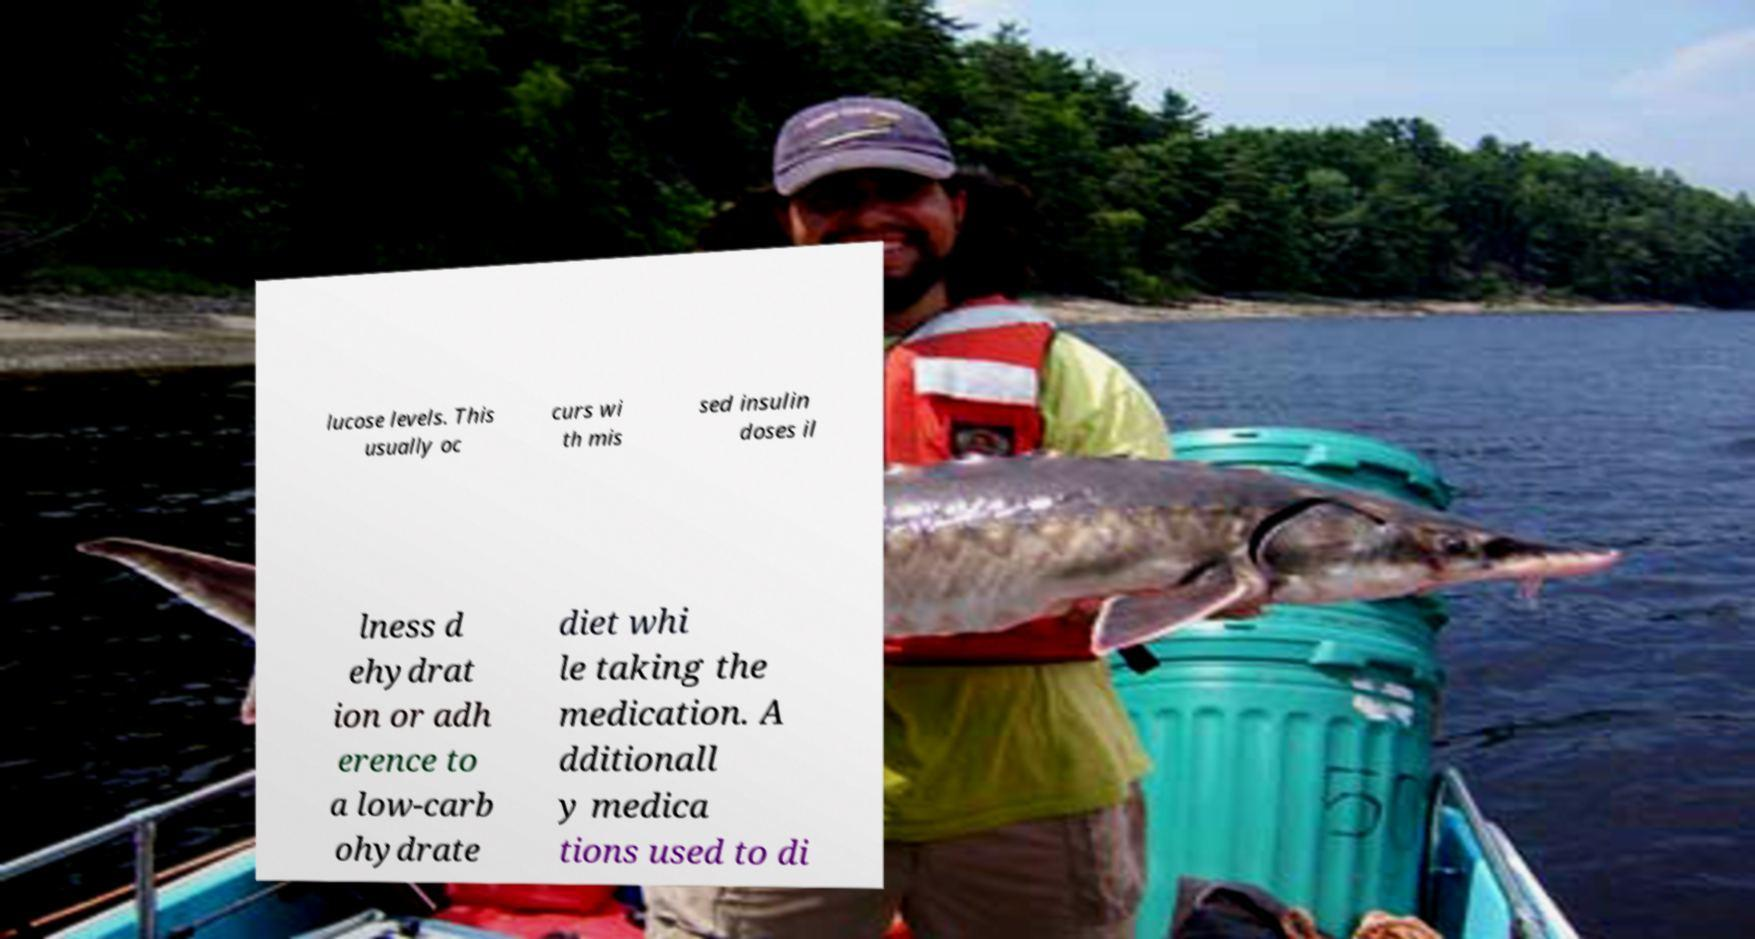Can you read and provide the text displayed in the image?This photo seems to have some interesting text. Can you extract and type it out for me? lucose levels. This usually oc curs wi th mis sed insulin doses il lness d ehydrat ion or adh erence to a low-carb ohydrate diet whi le taking the medication. A dditionall y medica tions used to di 